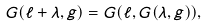Convert formula to latex. <formula><loc_0><loc_0><loc_500><loc_500>G ( \ell + \lambda , g ) = G ( \ell , G ( \lambda , g ) ) ,</formula> 